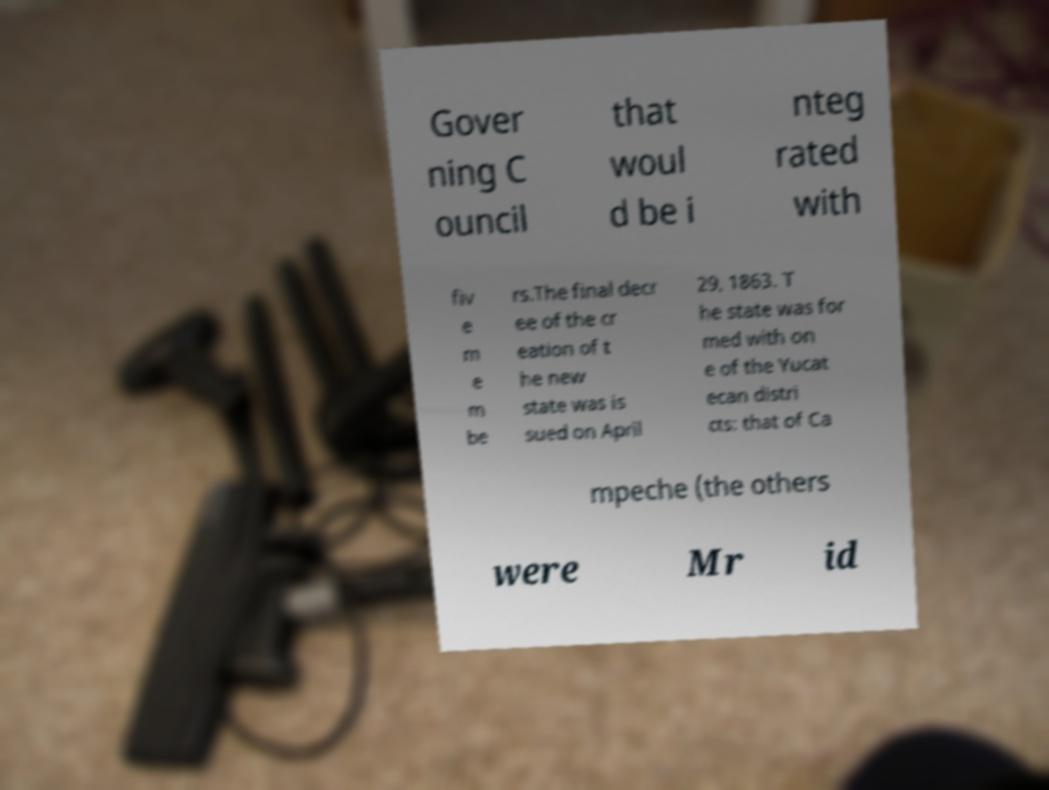I need the written content from this picture converted into text. Can you do that? Gover ning C ouncil that woul d be i nteg rated with fiv e m e m be rs.The final decr ee of the cr eation of t he new state was is sued on April 29, 1863. T he state was for med with on e of the Yucat ecan distri cts: that of Ca mpeche (the others were Mr id 